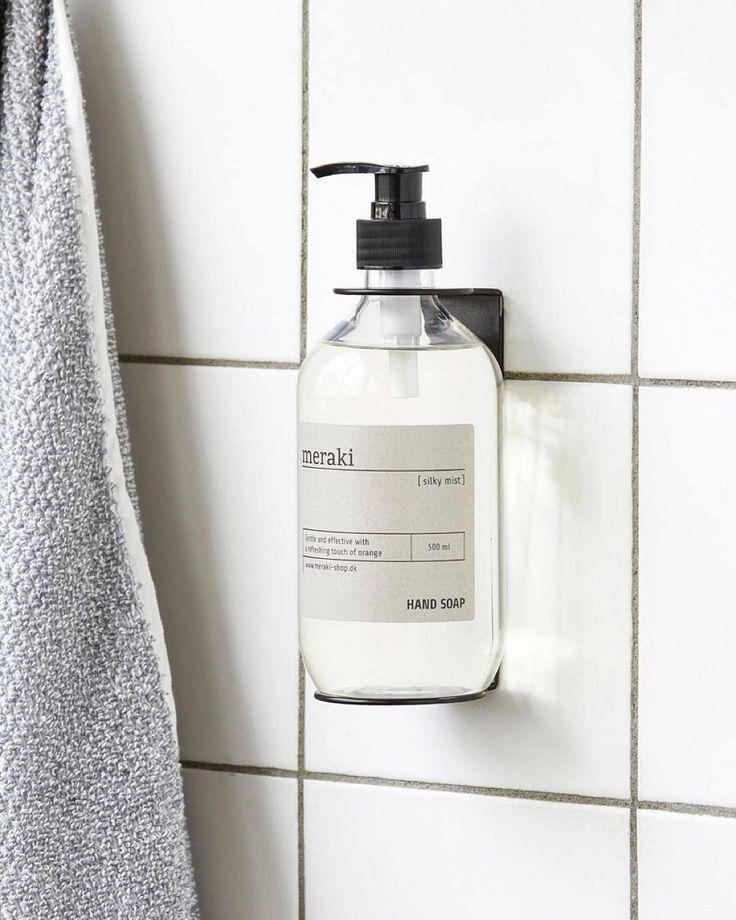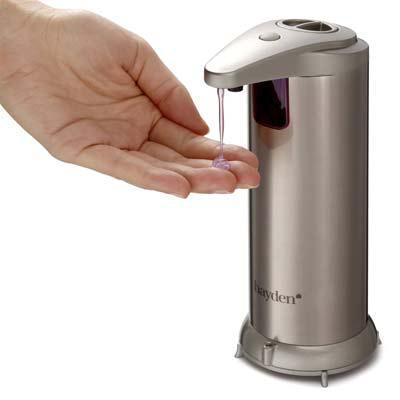The first image is the image on the left, the second image is the image on the right. For the images displayed, is the sentence "In one image soap is coming out of the dispenser." factually correct? Answer yes or no. Yes. The first image is the image on the left, the second image is the image on the right. Given the left and right images, does the statement "An image contains a human hand obtaining soap from a dispenser." hold true? Answer yes or no. Yes. 